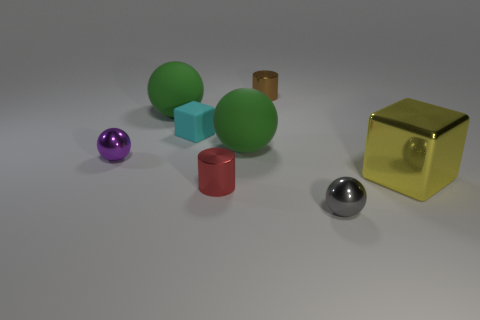What is the size of the other shiny object that is the same shape as the gray metal object?
Give a very brief answer. Small. There is a tiny metal cylinder that is in front of the tiny ball that is behind the gray metallic ball; how many red metal cylinders are left of it?
Offer a terse response. 0. Are there the same number of matte objects in front of the yellow block and tiny cyan rubber things?
Offer a terse response. No. How many blocks are small blue matte objects or big yellow shiny objects?
Offer a very short reply. 1. Is the big cube the same color as the small cube?
Your response must be concise. No. Are there an equal number of small cyan objects that are in front of the big yellow metal thing and spheres right of the small brown thing?
Offer a terse response. No. The large shiny thing has what color?
Provide a succinct answer. Yellow. What number of objects are either small spheres that are in front of the yellow shiny thing or large objects?
Offer a terse response. 4. There is a sphere that is behind the rubber cube; does it have the same size as the shiny cylinder that is in front of the tiny brown thing?
Offer a very short reply. No. Is there any other thing that has the same material as the red cylinder?
Offer a very short reply. Yes. 